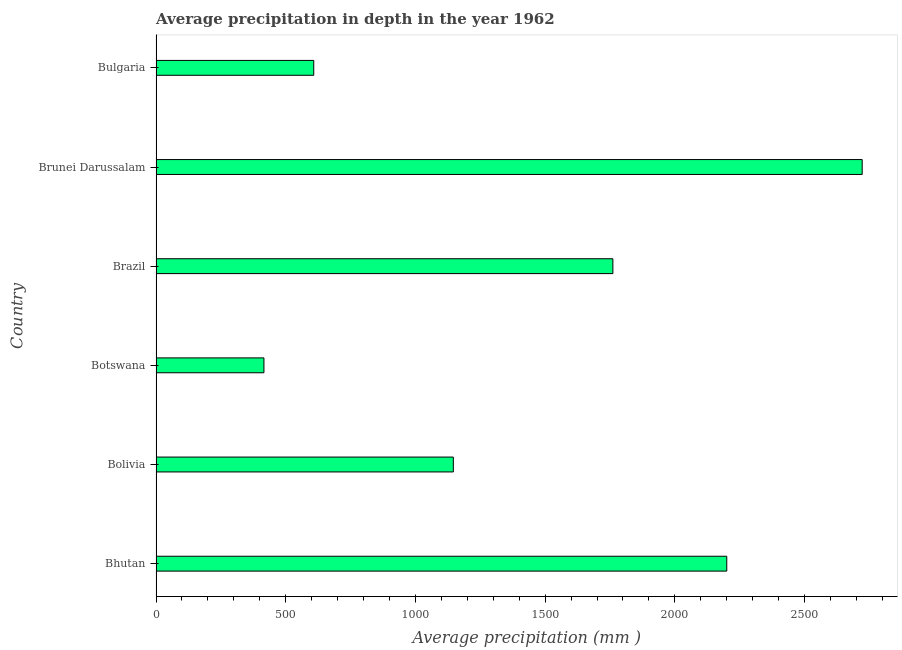Does the graph contain grids?
Make the answer very short. No. What is the title of the graph?
Your answer should be very brief. Average precipitation in depth in the year 1962. What is the label or title of the X-axis?
Make the answer very short. Average precipitation (mm ). What is the average precipitation in depth in Bulgaria?
Ensure brevity in your answer.  608. Across all countries, what is the maximum average precipitation in depth?
Provide a succinct answer. 2722. Across all countries, what is the minimum average precipitation in depth?
Your response must be concise. 416. In which country was the average precipitation in depth maximum?
Your answer should be very brief. Brunei Darussalam. In which country was the average precipitation in depth minimum?
Give a very brief answer. Botswana. What is the sum of the average precipitation in depth?
Give a very brief answer. 8853. What is the difference between the average precipitation in depth in Brazil and Brunei Darussalam?
Provide a succinct answer. -961. What is the average average precipitation in depth per country?
Your response must be concise. 1475. What is the median average precipitation in depth?
Provide a short and direct response. 1453.5. What is the ratio of the average precipitation in depth in Bhutan to that in Brazil?
Your answer should be compact. 1.25. What is the difference between the highest and the second highest average precipitation in depth?
Your answer should be compact. 522. Is the sum of the average precipitation in depth in Bolivia and Brazil greater than the maximum average precipitation in depth across all countries?
Provide a short and direct response. Yes. What is the difference between the highest and the lowest average precipitation in depth?
Your answer should be compact. 2306. In how many countries, is the average precipitation in depth greater than the average average precipitation in depth taken over all countries?
Provide a short and direct response. 3. How many bars are there?
Give a very brief answer. 6. What is the Average precipitation (mm ) in Bhutan?
Offer a terse response. 2200. What is the Average precipitation (mm ) in Bolivia?
Your answer should be very brief. 1146. What is the Average precipitation (mm ) of Botswana?
Ensure brevity in your answer.  416. What is the Average precipitation (mm ) in Brazil?
Your answer should be very brief. 1761. What is the Average precipitation (mm ) of Brunei Darussalam?
Provide a short and direct response. 2722. What is the Average precipitation (mm ) in Bulgaria?
Give a very brief answer. 608. What is the difference between the Average precipitation (mm ) in Bhutan and Bolivia?
Provide a succinct answer. 1054. What is the difference between the Average precipitation (mm ) in Bhutan and Botswana?
Your response must be concise. 1784. What is the difference between the Average precipitation (mm ) in Bhutan and Brazil?
Your response must be concise. 439. What is the difference between the Average precipitation (mm ) in Bhutan and Brunei Darussalam?
Make the answer very short. -522. What is the difference between the Average precipitation (mm ) in Bhutan and Bulgaria?
Offer a very short reply. 1592. What is the difference between the Average precipitation (mm ) in Bolivia and Botswana?
Offer a very short reply. 730. What is the difference between the Average precipitation (mm ) in Bolivia and Brazil?
Your answer should be compact. -615. What is the difference between the Average precipitation (mm ) in Bolivia and Brunei Darussalam?
Ensure brevity in your answer.  -1576. What is the difference between the Average precipitation (mm ) in Bolivia and Bulgaria?
Make the answer very short. 538. What is the difference between the Average precipitation (mm ) in Botswana and Brazil?
Give a very brief answer. -1345. What is the difference between the Average precipitation (mm ) in Botswana and Brunei Darussalam?
Make the answer very short. -2306. What is the difference between the Average precipitation (mm ) in Botswana and Bulgaria?
Provide a succinct answer. -192. What is the difference between the Average precipitation (mm ) in Brazil and Brunei Darussalam?
Provide a succinct answer. -961. What is the difference between the Average precipitation (mm ) in Brazil and Bulgaria?
Offer a terse response. 1153. What is the difference between the Average precipitation (mm ) in Brunei Darussalam and Bulgaria?
Make the answer very short. 2114. What is the ratio of the Average precipitation (mm ) in Bhutan to that in Bolivia?
Your answer should be compact. 1.92. What is the ratio of the Average precipitation (mm ) in Bhutan to that in Botswana?
Your response must be concise. 5.29. What is the ratio of the Average precipitation (mm ) in Bhutan to that in Brazil?
Ensure brevity in your answer.  1.25. What is the ratio of the Average precipitation (mm ) in Bhutan to that in Brunei Darussalam?
Your answer should be very brief. 0.81. What is the ratio of the Average precipitation (mm ) in Bhutan to that in Bulgaria?
Make the answer very short. 3.62. What is the ratio of the Average precipitation (mm ) in Bolivia to that in Botswana?
Offer a terse response. 2.75. What is the ratio of the Average precipitation (mm ) in Bolivia to that in Brazil?
Provide a succinct answer. 0.65. What is the ratio of the Average precipitation (mm ) in Bolivia to that in Brunei Darussalam?
Make the answer very short. 0.42. What is the ratio of the Average precipitation (mm ) in Bolivia to that in Bulgaria?
Make the answer very short. 1.89. What is the ratio of the Average precipitation (mm ) in Botswana to that in Brazil?
Give a very brief answer. 0.24. What is the ratio of the Average precipitation (mm ) in Botswana to that in Brunei Darussalam?
Give a very brief answer. 0.15. What is the ratio of the Average precipitation (mm ) in Botswana to that in Bulgaria?
Make the answer very short. 0.68. What is the ratio of the Average precipitation (mm ) in Brazil to that in Brunei Darussalam?
Ensure brevity in your answer.  0.65. What is the ratio of the Average precipitation (mm ) in Brazil to that in Bulgaria?
Provide a succinct answer. 2.9. What is the ratio of the Average precipitation (mm ) in Brunei Darussalam to that in Bulgaria?
Offer a very short reply. 4.48. 